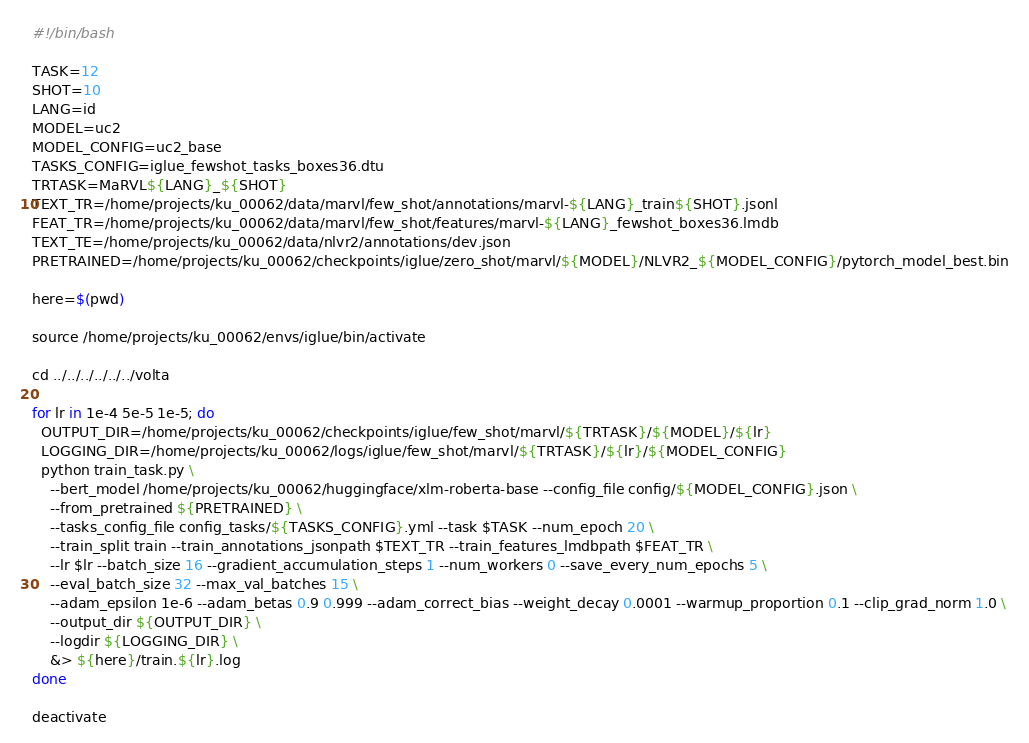Convert code to text. <code><loc_0><loc_0><loc_500><loc_500><_Bash_>#!/bin/bash

TASK=12
SHOT=10
LANG=id
MODEL=uc2
MODEL_CONFIG=uc2_base
TASKS_CONFIG=iglue_fewshot_tasks_boxes36.dtu
TRTASK=MaRVL${LANG}_${SHOT}
TEXT_TR=/home/projects/ku_00062/data/marvl/few_shot/annotations/marvl-${LANG}_train${SHOT}.jsonl
FEAT_TR=/home/projects/ku_00062/data/marvl/few_shot/features/marvl-${LANG}_fewshot_boxes36.lmdb
TEXT_TE=/home/projects/ku_00062/data/nlvr2/annotations/dev.json
PRETRAINED=/home/projects/ku_00062/checkpoints/iglue/zero_shot/marvl/${MODEL}/NLVR2_${MODEL_CONFIG}/pytorch_model_best.bin

here=$(pwd)

source /home/projects/ku_00062/envs/iglue/bin/activate

cd ../../../../../../volta

for lr in 1e-4 5e-5 1e-5; do
  OUTPUT_DIR=/home/projects/ku_00062/checkpoints/iglue/few_shot/marvl/${TRTASK}/${MODEL}/${lr}
  LOGGING_DIR=/home/projects/ku_00062/logs/iglue/few_shot/marvl/${TRTASK}/${lr}/${MODEL_CONFIG}
  python train_task.py \
    --bert_model /home/projects/ku_00062/huggingface/xlm-roberta-base --config_file config/${MODEL_CONFIG}.json \
    --from_pretrained ${PRETRAINED} \
    --tasks_config_file config_tasks/${TASKS_CONFIG}.yml --task $TASK --num_epoch 20 \
    --train_split train --train_annotations_jsonpath $TEXT_TR --train_features_lmdbpath $FEAT_TR \
    --lr $lr --batch_size 16 --gradient_accumulation_steps 1 --num_workers 0 --save_every_num_epochs 5 \
    --eval_batch_size 32 --max_val_batches 15 \
    --adam_epsilon 1e-6 --adam_betas 0.9 0.999 --adam_correct_bias --weight_decay 0.0001 --warmup_proportion 0.1 --clip_grad_norm 1.0 \
    --output_dir ${OUTPUT_DIR} \
    --logdir ${LOGGING_DIR} \
    &> ${here}/train.${lr}.log
done

deactivate
</code> 